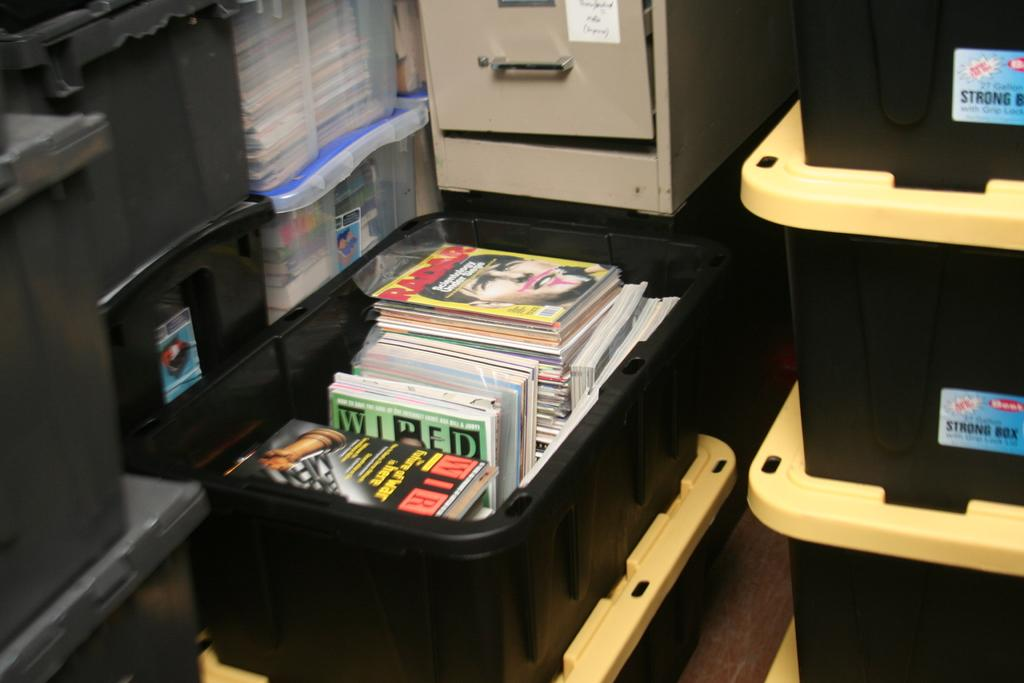<image>
Give a short and clear explanation of the subsequent image. The magazine on top of the pile is by Radar 